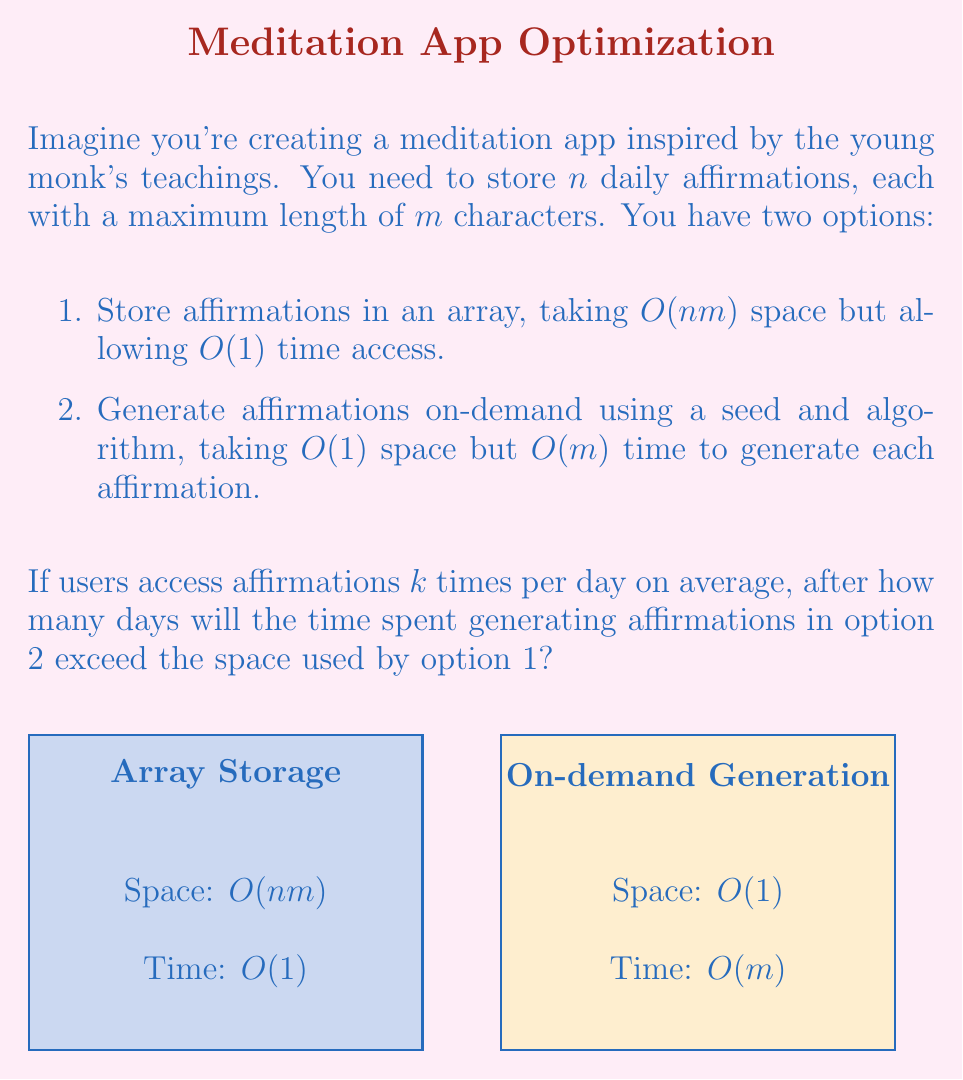Could you help me with this problem? Let's approach this step-by-step:

1) First, let's define our variables:
   $n$ = number of affirmations
   $m$ = maximum length of each affirmation
   $k$ = number of times affirmations are accessed per day
   $d$ = number of days

2) For option 1 (array storage), the space used is $O(nm)$.

3) For option 2 (on-demand generation), the time spent after $d$ days is:
   $O(kmd)$ (as we generate $k$ affirmations per day, each taking $O(m)$ time, for $d$ days)

4) We want to find when the time spent in option 2 exceeds the space used in option 1:
   $kmd > nm$

5) Solving for $d$:
   $d > \frac{n}{k}$

6) This means that after $\frac{n}{k}$ days, the time spent generating affirmations will exceed the space used by storing them.

7) However, we need the answer in whole days, so we take the ceiling of this value:
   $d = \left\lceil\frac{n}{k}\right\rceil$

This is the number of days after which the time spent generating affirmations will exceed the space used by storing them.
Answer: $\left\lceil\frac{n}{k}\right\rceil$ days 